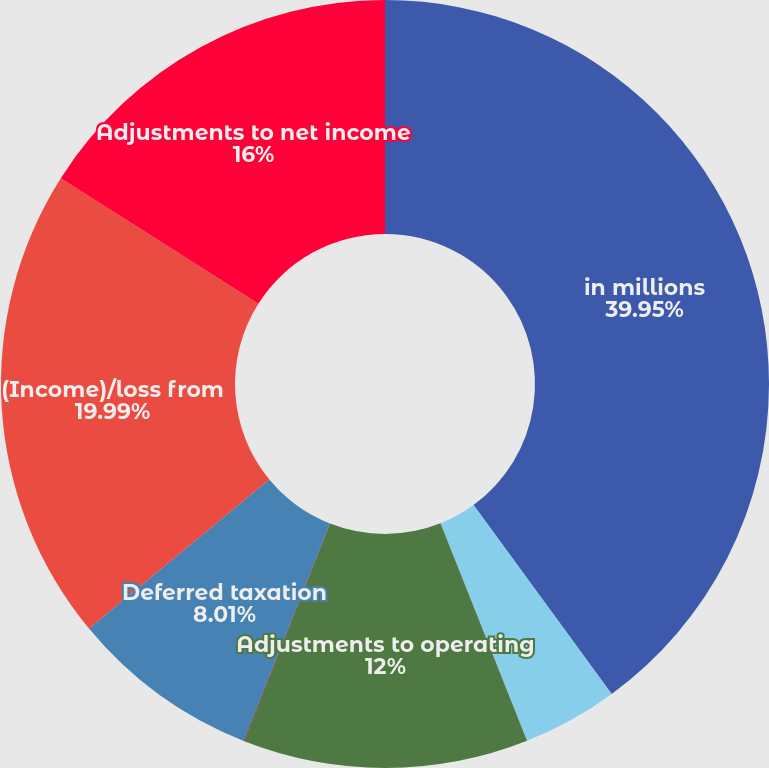<chart> <loc_0><loc_0><loc_500><loc_500><pie_chart><fcel>in millions<fcel>Intangible amortization<fcel>Adjustments to operating<fcel>Taxation on amortization<fcel>Deferred taxation<fcel>(Income)/loss from<fcel>Adjustments to net income<nl><fcel>39.95%<fcel>4.02%<fcel>12.0%<fcel>0.03%<fcel>8.01%<fcel>19.99%<fcel>16.0%<nl></chart> 